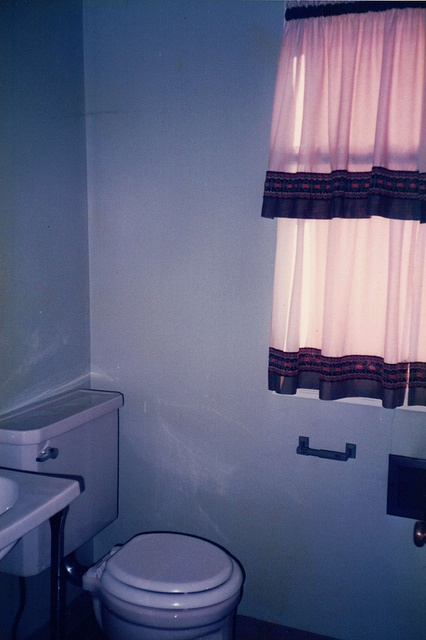Describe the objects in this image and their specific colors. I can see toilet in black, purple, gray, navy, and darkblue tones and sink in black, gray, blue, and darkblue tones in this image. 